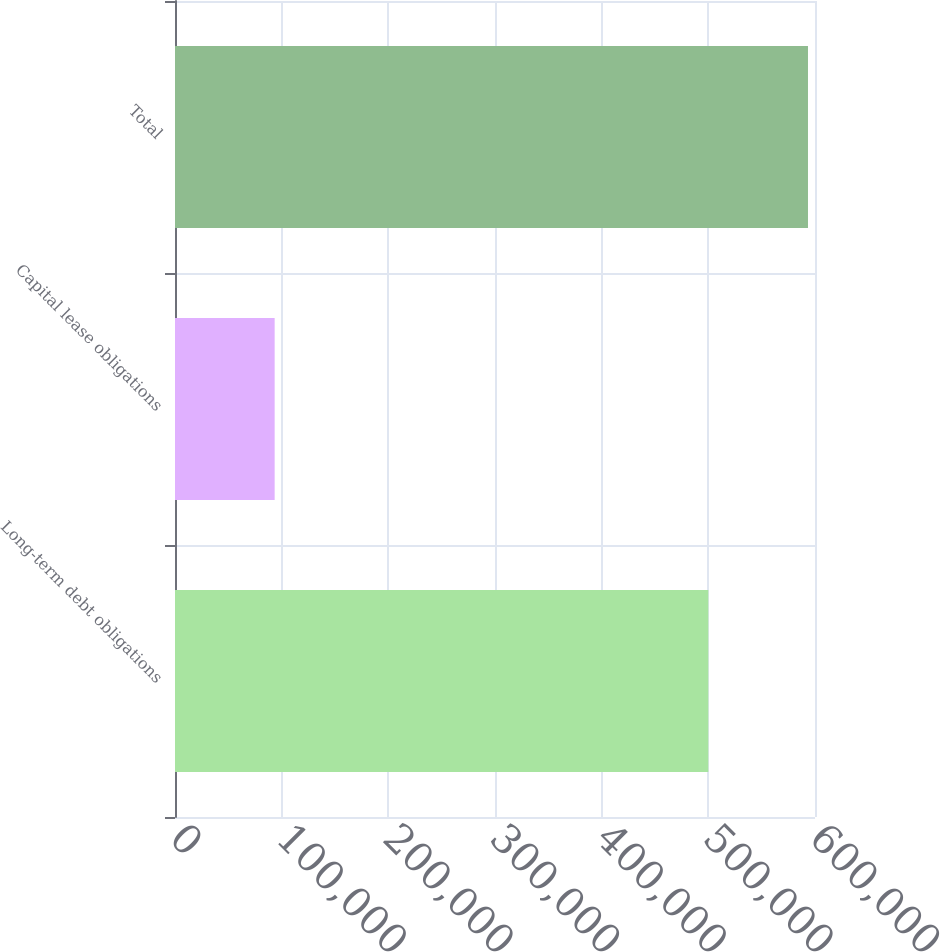<chart> <loc_0><loc_0><loc_500><loc_500><bar_chart><fcel>Long-term debt obligations<fcel>Capital lease obligations<fcel>Total<nl><fcel>500000<fcel>93426<fcel>593426<nl></chart> 